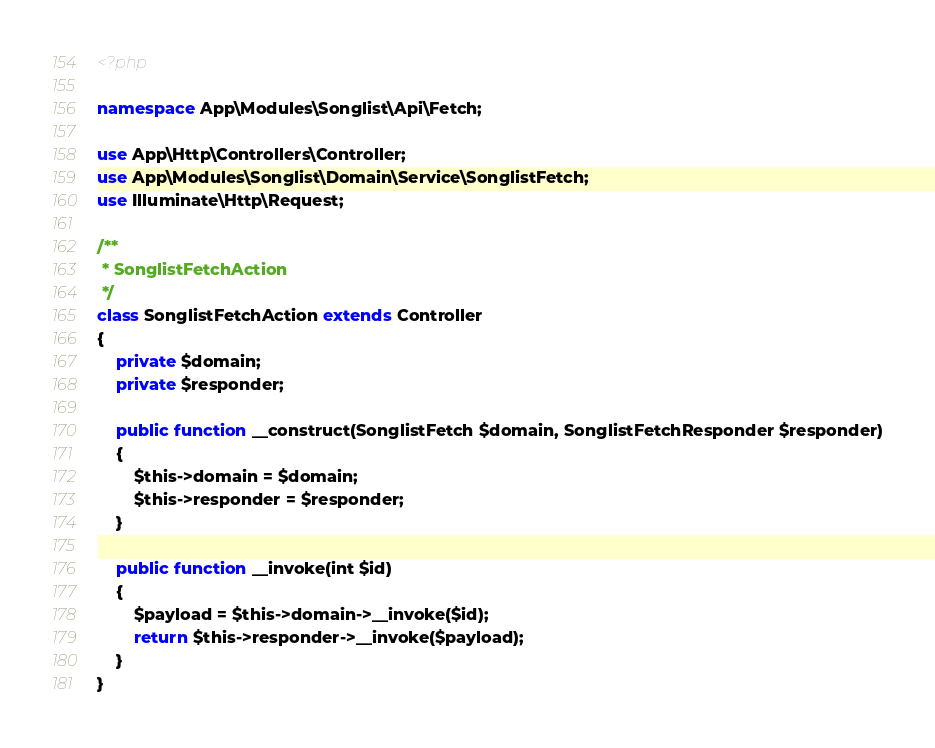Convert code to text. <code><loc_0><loc_0><loc_500><loc_500><_PHP_><?php

namespace App\Modules\Songlist\Api\Fetch;

use App\Http\Controllers\Controller;
use App\Modules\Songlist\Domain\Service\SonglistFetch;
use Illuminate\Http\Request;

/**
 * SonglistFetchAction
 */
class SonglistFetchAction extends Controller
{
    private $domain;
    private $responder;

    public function __construct(SonglistFetch $domain, SonglistFetchResponder $responder)
    {
        $this->domain = $domain;
        $this->responder = $responder;
    }

    public function __invoke(int $id)
    {
        $payload = $this->domain->__invoke($id);
        return $this->responder->__invoke($payload);
    }
}
</code> 